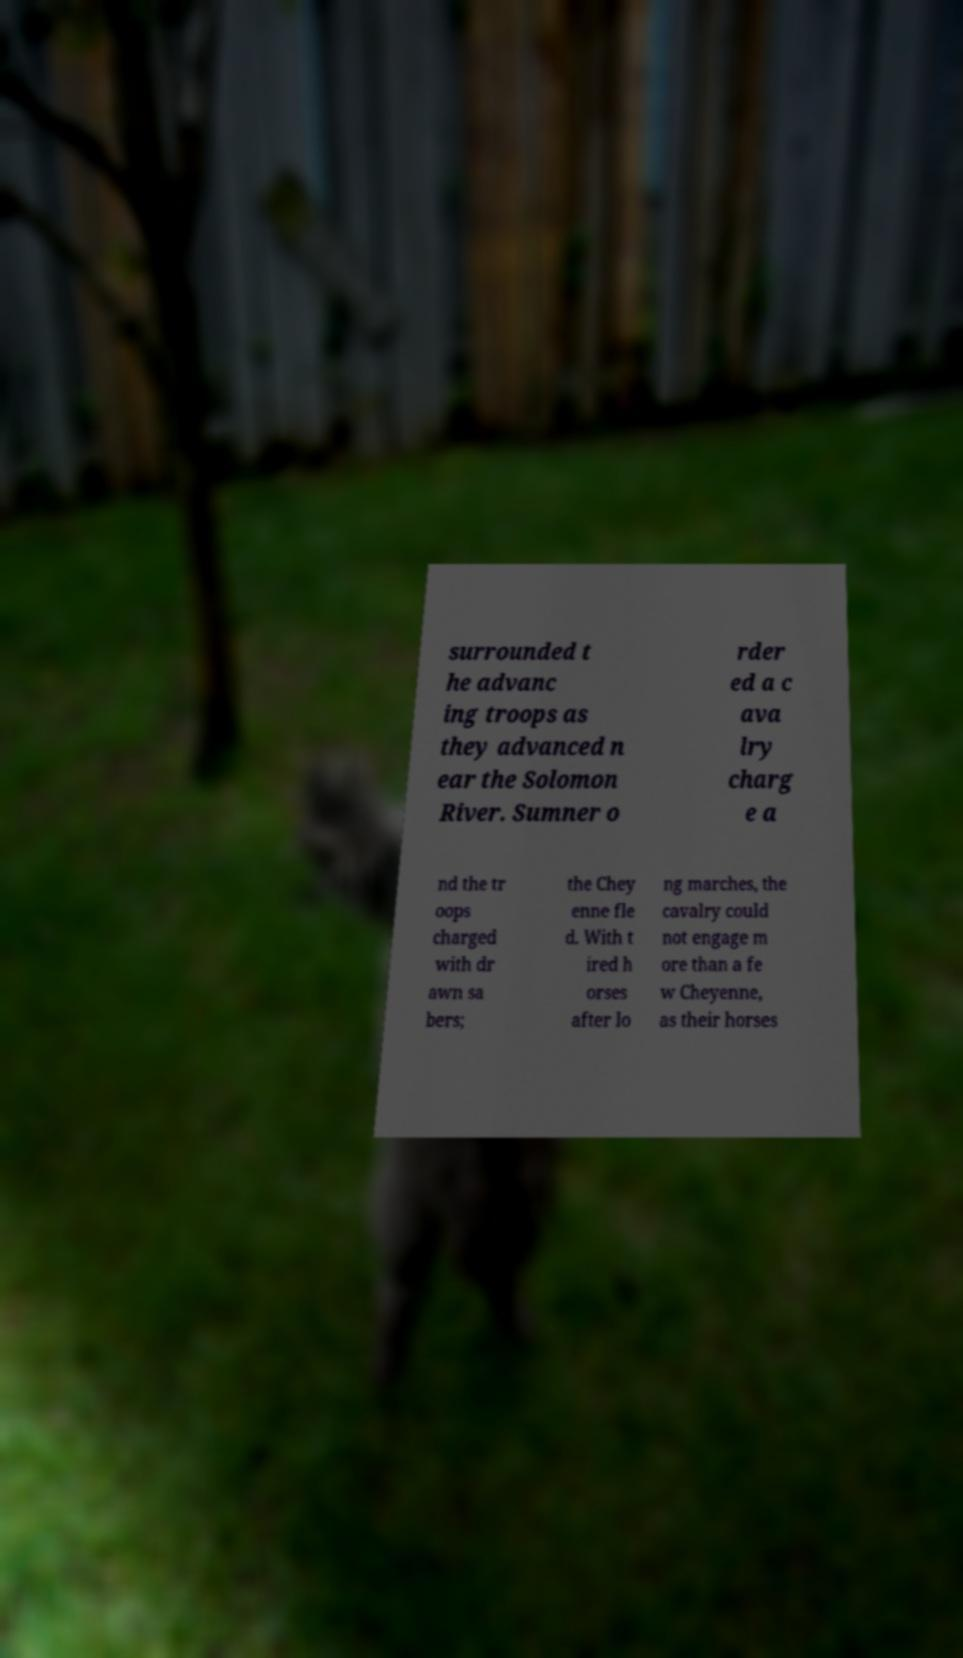Please identify and transcribe the text found in this image. surrounded t he advanc ing troops as they advanced n ear the Solomon River. Sumner o rder ed a c ava lry charg e a nd the tr oops charged with dr awn sa bers; the Chey enne fle d. With t ired h orses after lo ng marches, the cavalry could not engage m ore than a fe w Cheyenne, as their horses 